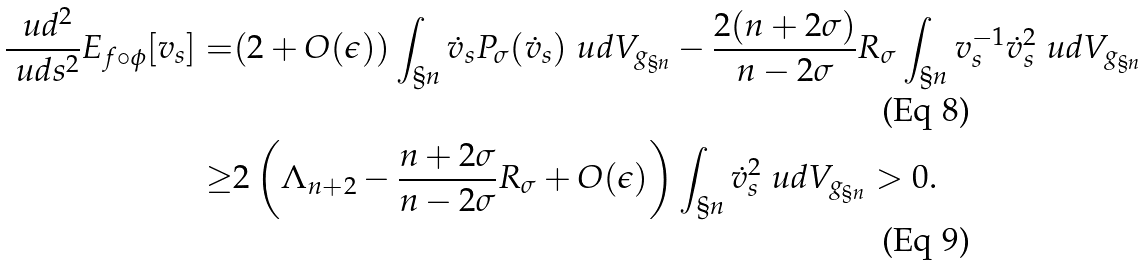<formula> <loc_0><loc_0><loc_500><loc_500>\frac { \ u d ^ { 2 } } { \ u d s ^ { 2 } } E _ { f \circ \phi } [ v _ { s } ] = & ( 2 + O ( \epsilon ) ) \int _ { \S n } \dot { v } _ { s } P _ { \sigma } ( \dot { v } _ { s } ) \ u d V _ { g _ { \S n } } - \frac { 2 ( n + 2 \sigma ) } { n - 2 \sigma } R _ { \sigma } \int _ { \S n } v _ { s } ^ { - 1 } \dot { v } _ { s } ^ { 2 } \ u d V _ { g _ { \S n } } \\ \geq & 2 \left ( \Lambda _ { n + 2 } - \frac { n + 2 \sigma } { n - 2 \sigma } R _ { \sigma } + O ( \epsilon ) \right ) \int _ { \S n } \dot { v } _ { s } ^ { 2 } \ u d V _ { g _ { \S n } } > 0 .</formula> 